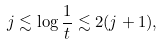Convert formula to latex. <formula><loc_0><loc_0><loc_500><loc_500>j \lesssim \log \frac { 1 } { t } \lesssim 2 ( j + 1 ) ,</formula> 